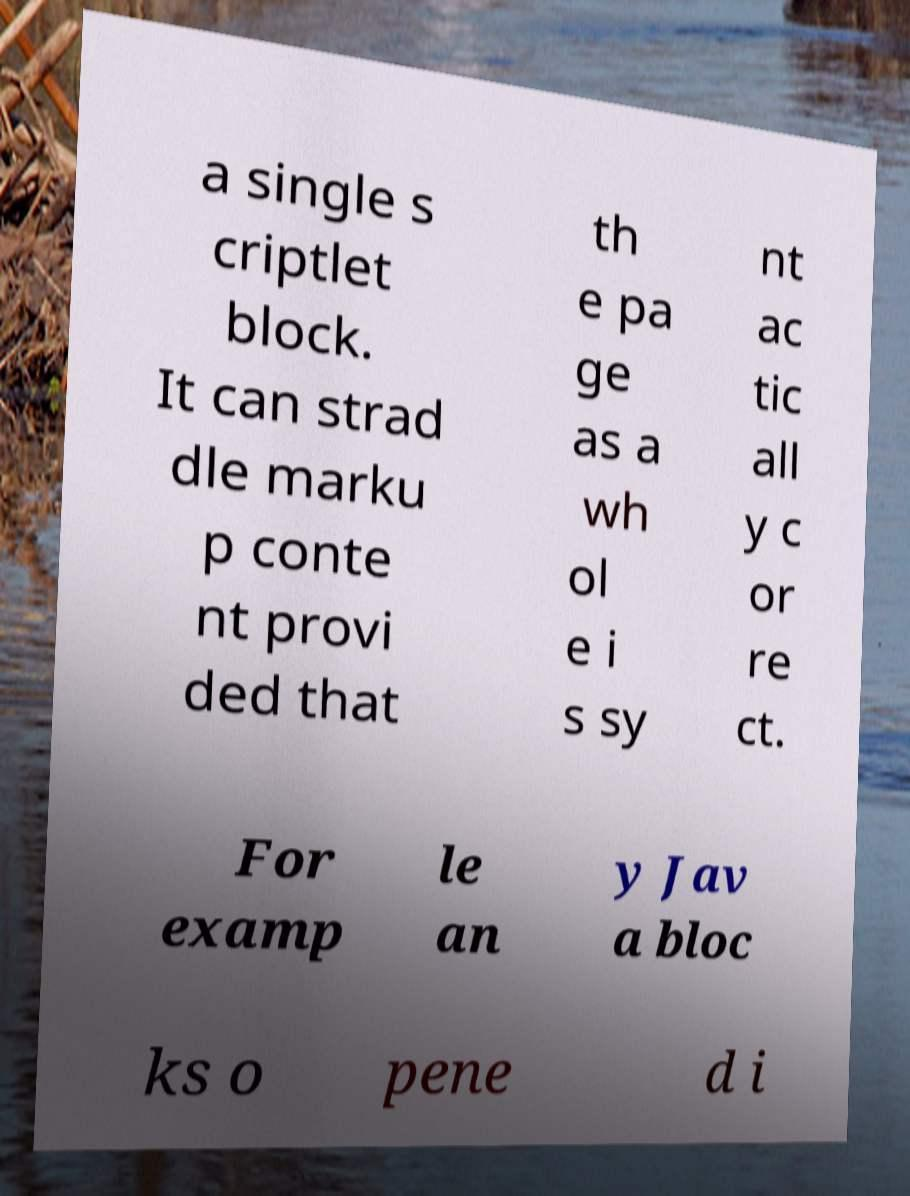I need the written content from this picture converted into text. Can you do that? a single s criptlet block. It can strad dle marku p conte nt provi ded that th e pa ge as a wh ol e i s sy nt ac tic all y c or re ct. For examp le an y Jav a bloc ks o pene d i 